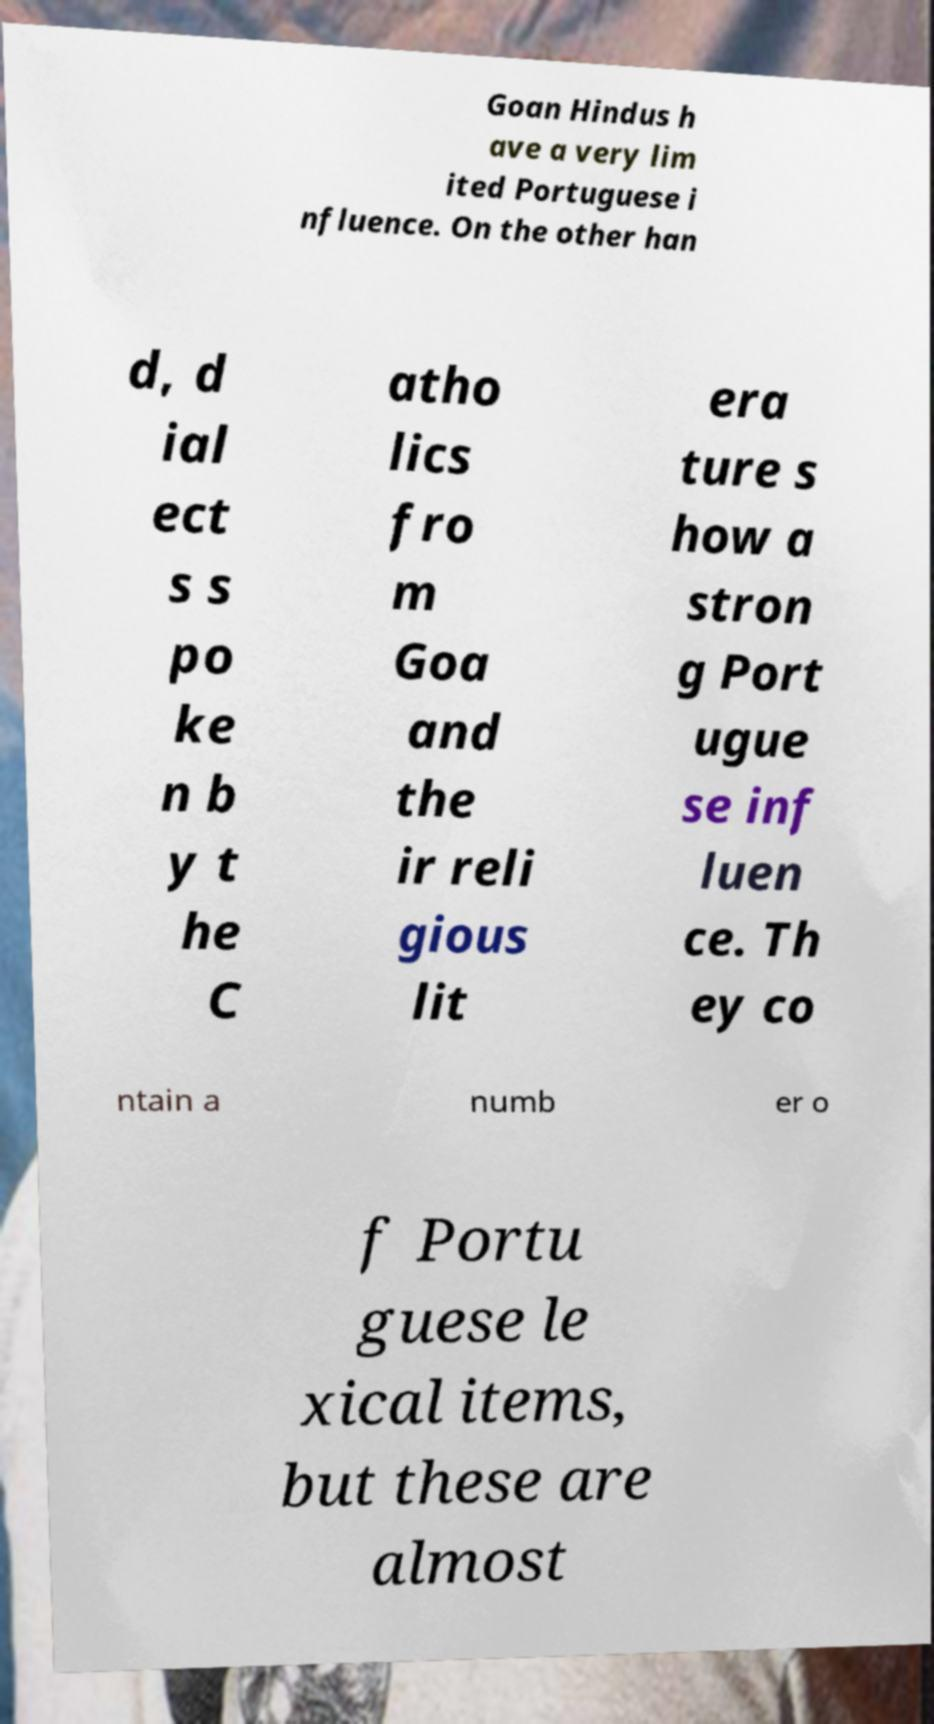Please identify and transcribe the text found in this image. Goan Hindus h ave a very lim ited Portuguese i nfluence. On the other han d, d ial ect s s po ke n b y t he C atho lics fro m Goa and the ir reli gious lit era ture s how a stron g Port ugue se inf luen ce. Th ey co ntain a numb er o f Portu guese le xical items, but these are almost 